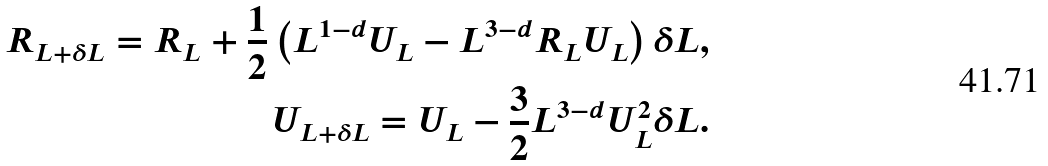<formula> <loc_0><loc_0><loc_500><loc_500>R _ { L + \delta L } = R _ { L } + \frac { 1 } { 2 } \left ( { L ^ { 1 - d } U _ { L } - L ^ { 3 - d } R _ { L } U _ { L } } \right ) \delta L , \\ U _ { L + \delta L } = U _ { L } - \frac { 3 } { 2 } L ^ { 3 - d } U _ { L } ^ { 2 } \delta L .</formula> 